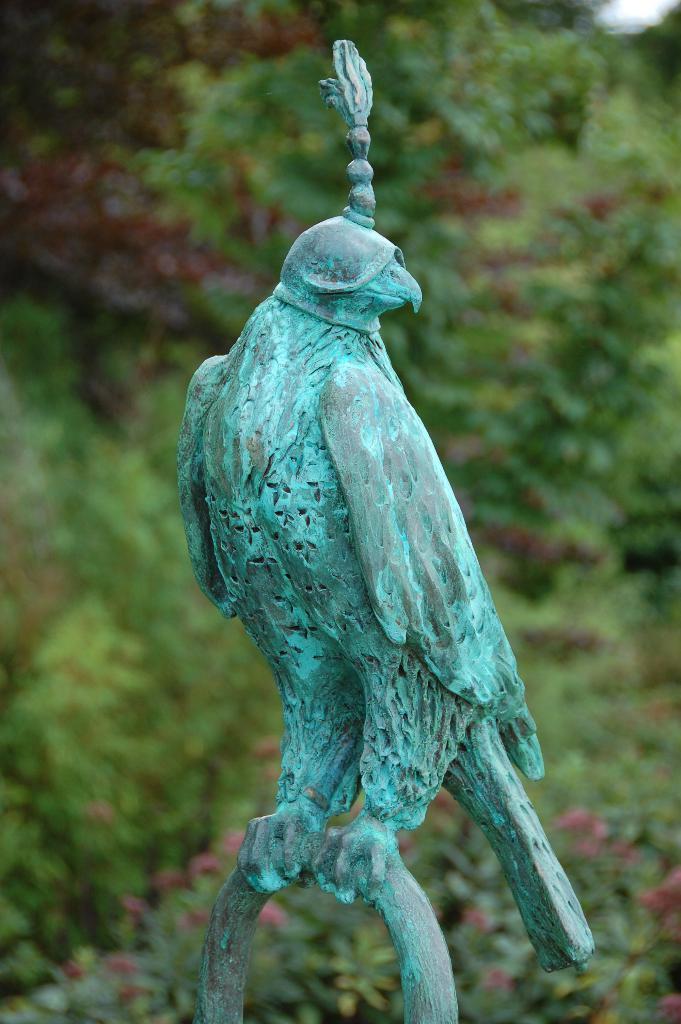Can you describe this image briefly? There is a statue of a bird, standing on an object. And the background is blurred. 